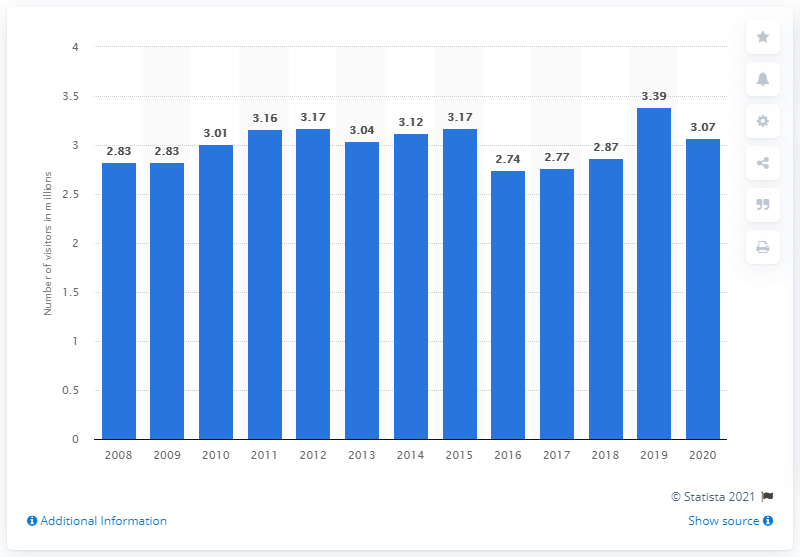Can you tell me more about the trend in visitation to the Chattahoochee River National Recreation Area over the past decade? Certainly, the bar chart indicates that the Chattahoochee River National Recreation Area has generally seen an increasing trend in the number of visitors over the past decade. Notably, there was a peak in 2019 with over 3.39 million visitors, while the visitation in 2020 declined slightly to around 3.07 million, possibly due to circumstances such as the COVID-19 pandemic. 